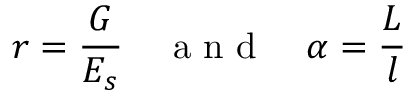Convert formula to latex. <formula><loc_0><loc_0><loc_500><loc_500>r = \frac { G } { E _ { s } } \quad a n d \quad \alpha = \frac { L } { l }</formula> 